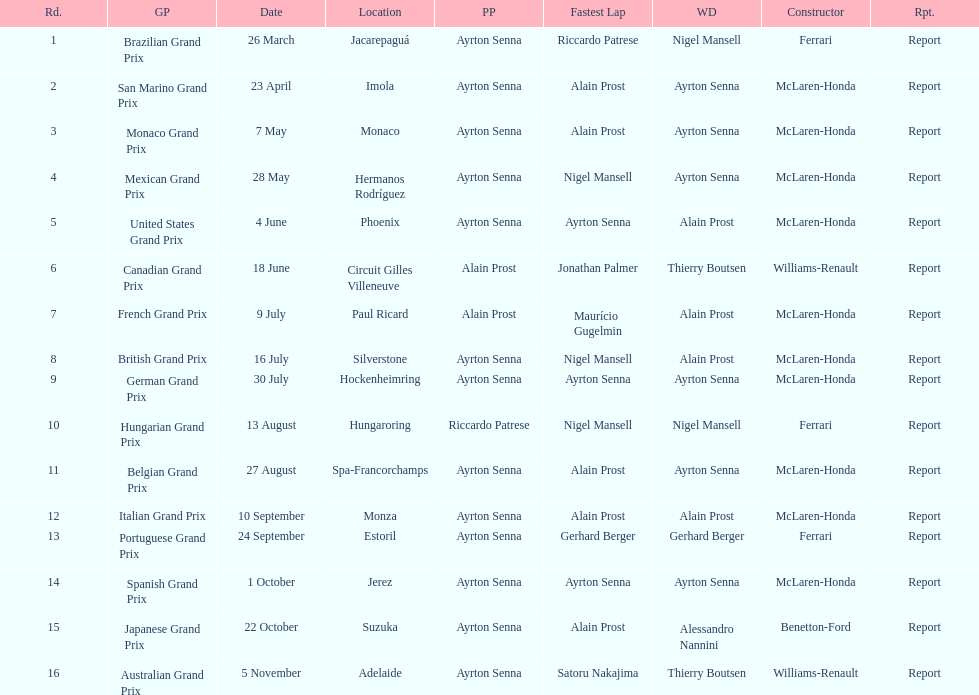What was the only grand prix to be won by benneton-ford? Japanese Grand Prix. 